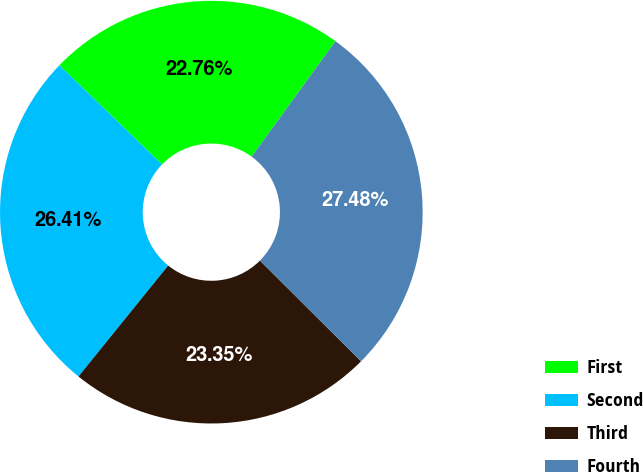Convert chart. <chart><loc_0><loc_0><loc_500><loc_500><pie_chart><fcel>First<fcel>Second<fcel>Third<fcel>Fourth<nl><fcel>22.76%<fcel>26.41%<fcel>23.35%<fcel>27.48%<nl></chart> 